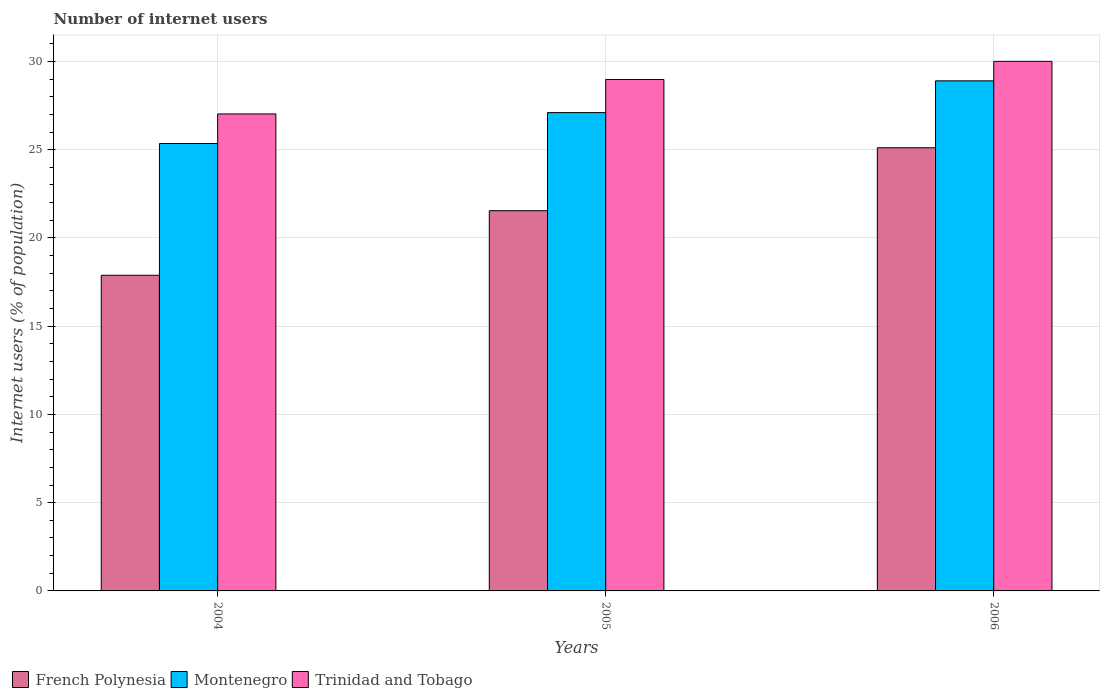How many groups of bars are there?
Keep it short and to the point. 3. Are the number of bars per tick equal to the number of legend labels?
Your response must be concise. Yes. What is the label of the 3rd group of bars from the left?
Provide a succinct answer. 2006. In how many cases, is the number of bars for a given year not equal to the number of legend labels?
Your answer should be compact. 0. What is the number of internet users in French Polynesia in 2005?
Offer a very short reply. 21.54. Across all years, what is the maximum number of internet users in Trinidad and Tobago?
Give a very brief answer. 30. Across all years, what is the minimum number of internet users in French Polynesia?
Offer a terse response. 17.88. What is the total number of internet users in French Polynesia in the graph?
Offer a very short reply. 64.53. What is the difference between the number of internet users in Trinidad and Tobago in 2005 and that in 2006?
Offer a terse response. -1.03. What is the difference between the number of internet users in Trinidad and Tobago in 2006 and the number of internet users in French Polynesia in 2004?
Offer a very short reply. 12.12. What is the average number of internet users in Trinidad and Tobago per year?
Offer a terse response. 28.67. In the year 2005, what is the difference between the number of internet users in Trinidad and Tobago and number of internet users in French Polynesia?
Make the answer very short. 7.43. In how many years, is the number of internet users in Trinidad and Tobago greater than 4 %?
Provide a succinct answer. 3. What is the ratio of the number of internet users in Montenegro in 2005 to that in 2006?
Give a very brief answer. 0.94. Is the number of internet users in French Polynesia in 2005 less than that in 2006?
Ensure brevity in your answer.  Yes. What is the difference between the highest and the second highest number of internet users in Montenegro?
Ensure brevity in your answer.  1.8. What is the difference between the highest and the lowest number of internet users in Trinidad and Tobago?
Your answer should be compact. 2.98. In how many years, is the number of internet users in Montenegro greater than the average number of internet users in Montenegro taken over all years?
Your answer should be very brief. 1. Is the sum of the number of internet users in French Polynesia in 2004 and 2005 greater than the maximum number of internet users in Trinidad and Tobago across all years?
Provide a short and direct response. Yes. What does the 1st bar from the left in 2004 represents?
Provide a short and direct response. French Polynesia. What does the 1st bar from the right in 2004 represents?
Offer a terse response. Trinidad and Tobago. Is it the case that in every year, the sum of the number of internet users in French Polynesia and number of internet users in Trinidad and Tobago is greater than the number of internet users in Montenegro?
Give a very brief answer. Yes. How many bars are there?
Keep it short and to the point. 9. How many years are there in the graph?
Offer a very short reply. 3. Are the values on the major ticks of Y-axis written in scientific E-notation?
Make the answer very short. No. Does the graph contain any zero values?
Provide a short and direct response. No. How many legend labels are there?
Give a very brief answer. 3. What is the title of the graph?
Offer a very short reply. Number of internet users. What is the label or title of the Y-axis?
Provide a short and direct response. Internet users (% of population). What is the Internet users (% of population) of French Polynesia in 2004?
Your answer should be very brief. 17.88. What is the Internet users (% of population) of Montenegro in 2004?
Your response must be concise. 25.35. What is the Internet users (% of population) in Trinidad and Tobago in 2004?
Offer a very short reply. 27.02. What is the Internet users (% of population) in French Polynesia in 2005?
Offer a terse response. 21.54. What is the Internet users (% of population) in Montenegro in 2005?
Offer a terse response. 27.1. What is the Internet users (% of population) in Trinidad and Tobago in 2005?
Your answer should be compact. 28.98. What is the Internet users (% of population) in French Polynesia in 2006?
Ensure brevity in your answer.  25.11. What is the Internet users (% of population) in Montenegro in 2006?
Offer a very short reply. 28.9. What is the Internet users (% of population) in Trinidad and Tobago in 2006?
Your answer should be compact. 30. Across all years, what is the maximum Internet users (% of population) of French Polynesia?
Offer a terse response. 25.11. Across all years, what is the maximum Internet users (% of population) in Montenegro?
Ensure brevity in your answer.  28.9. Across all years, what is the maximum Internet users (% of population) in Trinidad and Tobago?
Offer a very short reply. 30. Across all years, what is the minimum Internet users (% of population) in French Polynesia?
Your answer should be compact. 17.88. Across all years, what is the minimum Internet users (% of population) in Montenegro?
Give a very brief answer. 25.35. Across all years, what is the minimum Internet users (% of population) in Trinidad and Tobago?
Offer a very short reply. 27.02. What is the total Internet users (% of population) of French Polynesia in the graph?
Your answer should be very brief. 64.53. What is the total Internet users (% of population) in Montenegro in the graph?
Provide a succinct answer. 81.35. What is the total Internet users (% of population) of Trinidad and Tobago in the graph?
Ensure brevity in your answer.  86. What is the difference between the Internet users (% of population) of French Polynesia in 2004 and that in 2005?
Give a very brief answer. -3.66. What is the difference between the Internet users (% of population) in Montenegro in 2004 and that in 2005?
Offer a terse response. -1.75. What is the difference between the Internet users (% of population) in Trinidad and Tobago in 2004 and that in 2005?
Ensure brevity in your answer.  -1.95. What is the difference between the Internet users (% of population) of French Polynesia in 2004 and that in 2006?
Your answer should be very brief. -7.22. What is the difference between the Internet users (% of population) in Montenegro in 2004 and that in 2006?
Keep it short and to the point. -3.55. What is the difference between the Internet users (% of population) of Trinidad and Tobago in 2004 and that in 2006?
Ensure brevity in your answer.  -2.98. What is the difference between the Internet users (% of population) in French Polynesia in 2005 and that in 2006?
Make the answer very short. -3.57. What is the difference between the Internet users (% of population) of Trinidad and Tobago in 2005 and that in 2006?
Your answer should be very brief. -1.03. What is the difference between the Internet users (% of population) of French Polynesia in 2004 and the Internet users (% of population) of Montenegro in 2005?
Give a very brief answer. -9.22. What is the difference between the Internet users (% of population) in French Polynesia in 2004 and the Internet users (% of population) in Trinidad and Tobago in 2005?
Provide a succinct answer. -11.09. What is the difference between the Internet users (% of population) of Montenegro in 2004 and the Internet users (% of population) of Trinidad and Tobago in 2005?
Make the answer very short. -3.63. What is the difference between the Internet users (% of population) in French Polynesia in 2004 and the Internet users (% of population) in Montenegro in 2006?
Ensure brevity in your answer.  -11.02. What is the difference between the Internet users (% of population) in French Polynesia in 2004 and the Internet users (% of population) in Trinidad and Tobago in 2006?
Offer a terse response. -12.12. What is the difference between the Internet users (% of population) in Montenegro in 2004 and the Internet users (% of population) in Trinidad and Tobago in 2006?
Offer a terse response. -4.65. What is the difference between the Internet users (% of population) in French Polynesia in 2005 and the Internet users (% of population) in Montenegro in 2006?
Make the answer very short. -7.36. What is the difference between the Internet users (% of population) in French Polynesia in 2005 and the Internet users (% of population) in Trinidad and Tobago in 2006?
Offer a very short reply. -8.46. What is the difference between the Internet users (% of population) of Montenegro in 2005 and the Internet users (% of population) of Trinidad and Tobago in 2006?
Offer a very short reply. -2.9. What is the average Internet users (% of population) in French Polynesia per year?
Your response must be concise. 21.51. What is the average Internet users (% of population) of Montenegro per year?
Offer a very short reply. 27.12. What is the average Internet users (% of population) in Trinidad and Tobago per year?
Make the answer very short. 28.67. In the year 2004, what is the difference between the Internet users (% of population) of French Polynesia and Internet users (% of population) of Montenegro?
Provide a succinct answer. -7.47. In the year 2004, what is the difference between the Internet users (% of population) in French Polynesia and Internet users (% of population) in Trinidad and Tobago?
Provide a succinct answer. -9.14. In the year 2004, what is the difference between the Internet users (% of population) in Montenegro and Internet users (% of population) in Trinidad and Tobago?
Give a very brief answer. -1.67. In the year 2005, what is the difference between the Internet users (% of population) of French Polynesia and Internet users (% of population) of Montenegro?
Your response must be concise. -5.56. In the year 2005, what is the difference between the Internet users (% of population) in French Polynesia and Internet users (% of population) in Trinidad and Tobago?
Keep it short and to the point. -7.43. In the year 2005, what is the difference between the Internet users (% of population) of Montenegro and Internet users (% of population) of Trinidad and Tobago?
Offer a very short reply. -1.88. In the year 2006, what is the difference between the Internet users (% of population) of French Polynesia and Internet users (% of population) of Montenegro?
Offer a very short reply. -3.79. In the year 2006, what is the difference between the Internet users (% of population) in French Polynesia and Internet users (% of population) in Trinidad and Tobago?
Make the answer very short. -4.9. In the year 2006, what is the difference between the Internet users (% of population) in Montenegro and Internet users (% of population) in Trinidad and Tobago?
Your response must be concise. -1.1. What is the ratio of the Internet users (% of population) of French Polynesia in 2004 to that in 2005?
Provide a short and direct response. 0.83. What is the ratio of the Internet users (% of population) of Montenegro in 2004 to that in 2005?
Keep it short and to the point. 0.94. What is the ratio of the Internet users (% of population) in Trinidad and Tobago in 2004 to that in 2005?
Your answer should be compact. 0.93. What is the ratio of the Internet users (% of population) in French Polynesia in 2004 to that in 2006?
Offer a terse response. 0.71. What is the ratio of the Internet users (% of population) of Montenegro in 2004 to that in 2006?
Provide a succinct answer. 0.88. What is the ratio of the Internet users (% of population) in Trinidad and Tobago in 2004 to that in 2006?
Offer a terse response. 0.9. What is the ratio of the Internet users (% of population) in French Polynesia in 2005 to that in 2006?
Your answer should be compact. 0.86. What is the ratio of the Internet users (% of population) of Montenegro in 2005 to that in 2006?
Ensure brevity in your answer.  0.94. What is the ratio of the Internet users (% of population) of Trinidad and Tobago in 2005 to that in 2006?
Offer a terse response. 0.97. What is the difference between the highest and the second highest Internet users (% of population) in French Polynesia?
Offer a terse response. 3.57. What is the difference between the highest and the lowest Internet users (% of population) of French Polynesia?
Offer a terse response. 7.22. What is the difference between the highest and the lowest Internet users (% of population) of Montenegro?
Offer a terse response. 3.55. What is the difference between the highest and the lowest Internet users (% of population) in Trinidad and Tobago?
Provide a short and direct response. 2.98. 